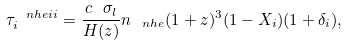Convert formula to latex. <formula><loc_0><loc_0><loc_500><loc_500>\tau _ { i } ^ { \ n h e i i } = \frac { c \ \sigma _ { l } } { H ( z ) } n _ { \ n h e } ( 1 + z ) ^ { 3 } ( 1 - X _ { i } ) ( 1 + \delta _ { i } ) ,</formula> 